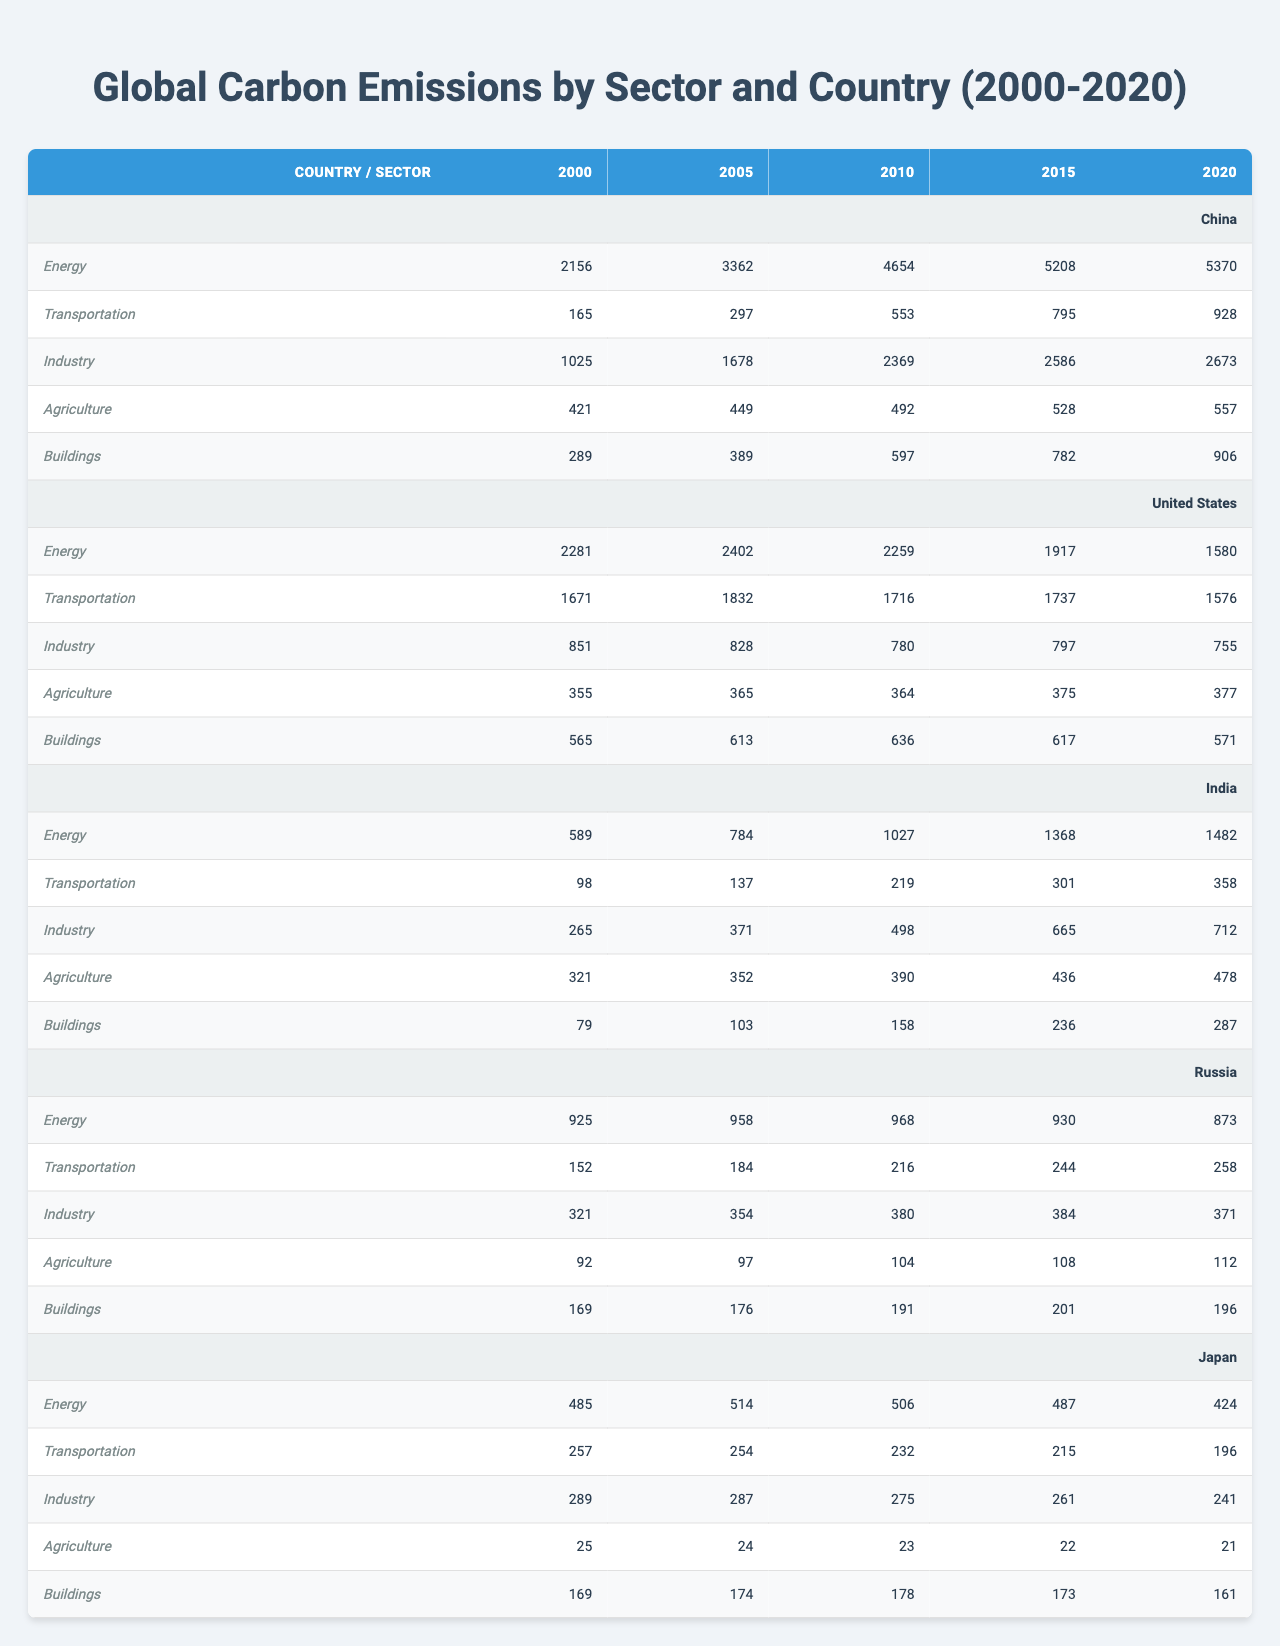What were China's carbon emissions in the Energy sector in 2020? Referring to the table, China's carbon emissions in the Energy sector for 2020 is listed as 5370.
Answer: 5370 What was the total carbon emissions from the Transportation sector for the United States from 2000 to 2020? To find the total, we sum the values: 1671 + 1832 + 1716 + 1737 + 1576 = 10732.
Answer: 10732 Did Japan's carbon emissions in the Industry sector increase from 2000 to 2020? Looking at the data for Japan in the Industry sector, the values are 289 in 2000 and 241 in 2020. Since 241 is less than 289, we can conclude that emissions decreased.
Answer: No Which country had the highest carbon emissions in the Agriculture sector in 2015? In the Agriculture sector for 2015, China had emissions of 528, the United States had 375, India had 436, Russia had 108, and Japan had 22. The highest is China's 528.
Answer: China What is the difference in carbon emissions from the Energy sector between India in 2020 and the United States in the same year? India's emissions in the Energy sector in 2020 are 1482, while the United States' are 1580. The difference is 1580 - 1482 = 98.
Answer: 98 What were the average carbon emissions in the Industry sector across all countries in 2020? The Industry sector emissions in 2020 are: China 2673, United States 755, India 712, Russia 371, Japan 241. The sum is 2673 + 755 + 712 + 371 + 241 = 4832. There are 5 countries, so the average is 4832 / 5 = 966.4.
Answer: 966.4 In which sector did Russia experience the highest carbon emissions in 2005? The table shows that for Russia in 2005, the emissions were: Energy 958, Transportation 184, Industry 354, Agriculture 97, and Buildings 176. The highest value is from the Energy sector at 958.
Answer: Energy Which country had the lowest carbon emissions in the Buildings sector in 2010? For the Buildings sector in 2010, the emissions were: China 597, United States 636, India 158, Russia 191, and Japan 178. The lowest emissions value is from India at 158.
Answer: India What was the trend of carbon emissions in the Buildings sector for the United States from 2000 to 2020? The emissions for the United States in the Buildings sector over the years are: 565, 613, 636, 617, 571. These values first increase, peaking at 636 in 2010, then decrease to 571 in 2020, showing a peak followed by a decline.
Answer: Peaks then declines What were the overall carbon emissions from the Agriculture sector for India from 2000 to 2020? The total emissions in the Agriculture sector for India are 321 + 352 + 390 + 436 + 478 = 1977.
Answer: 1977 